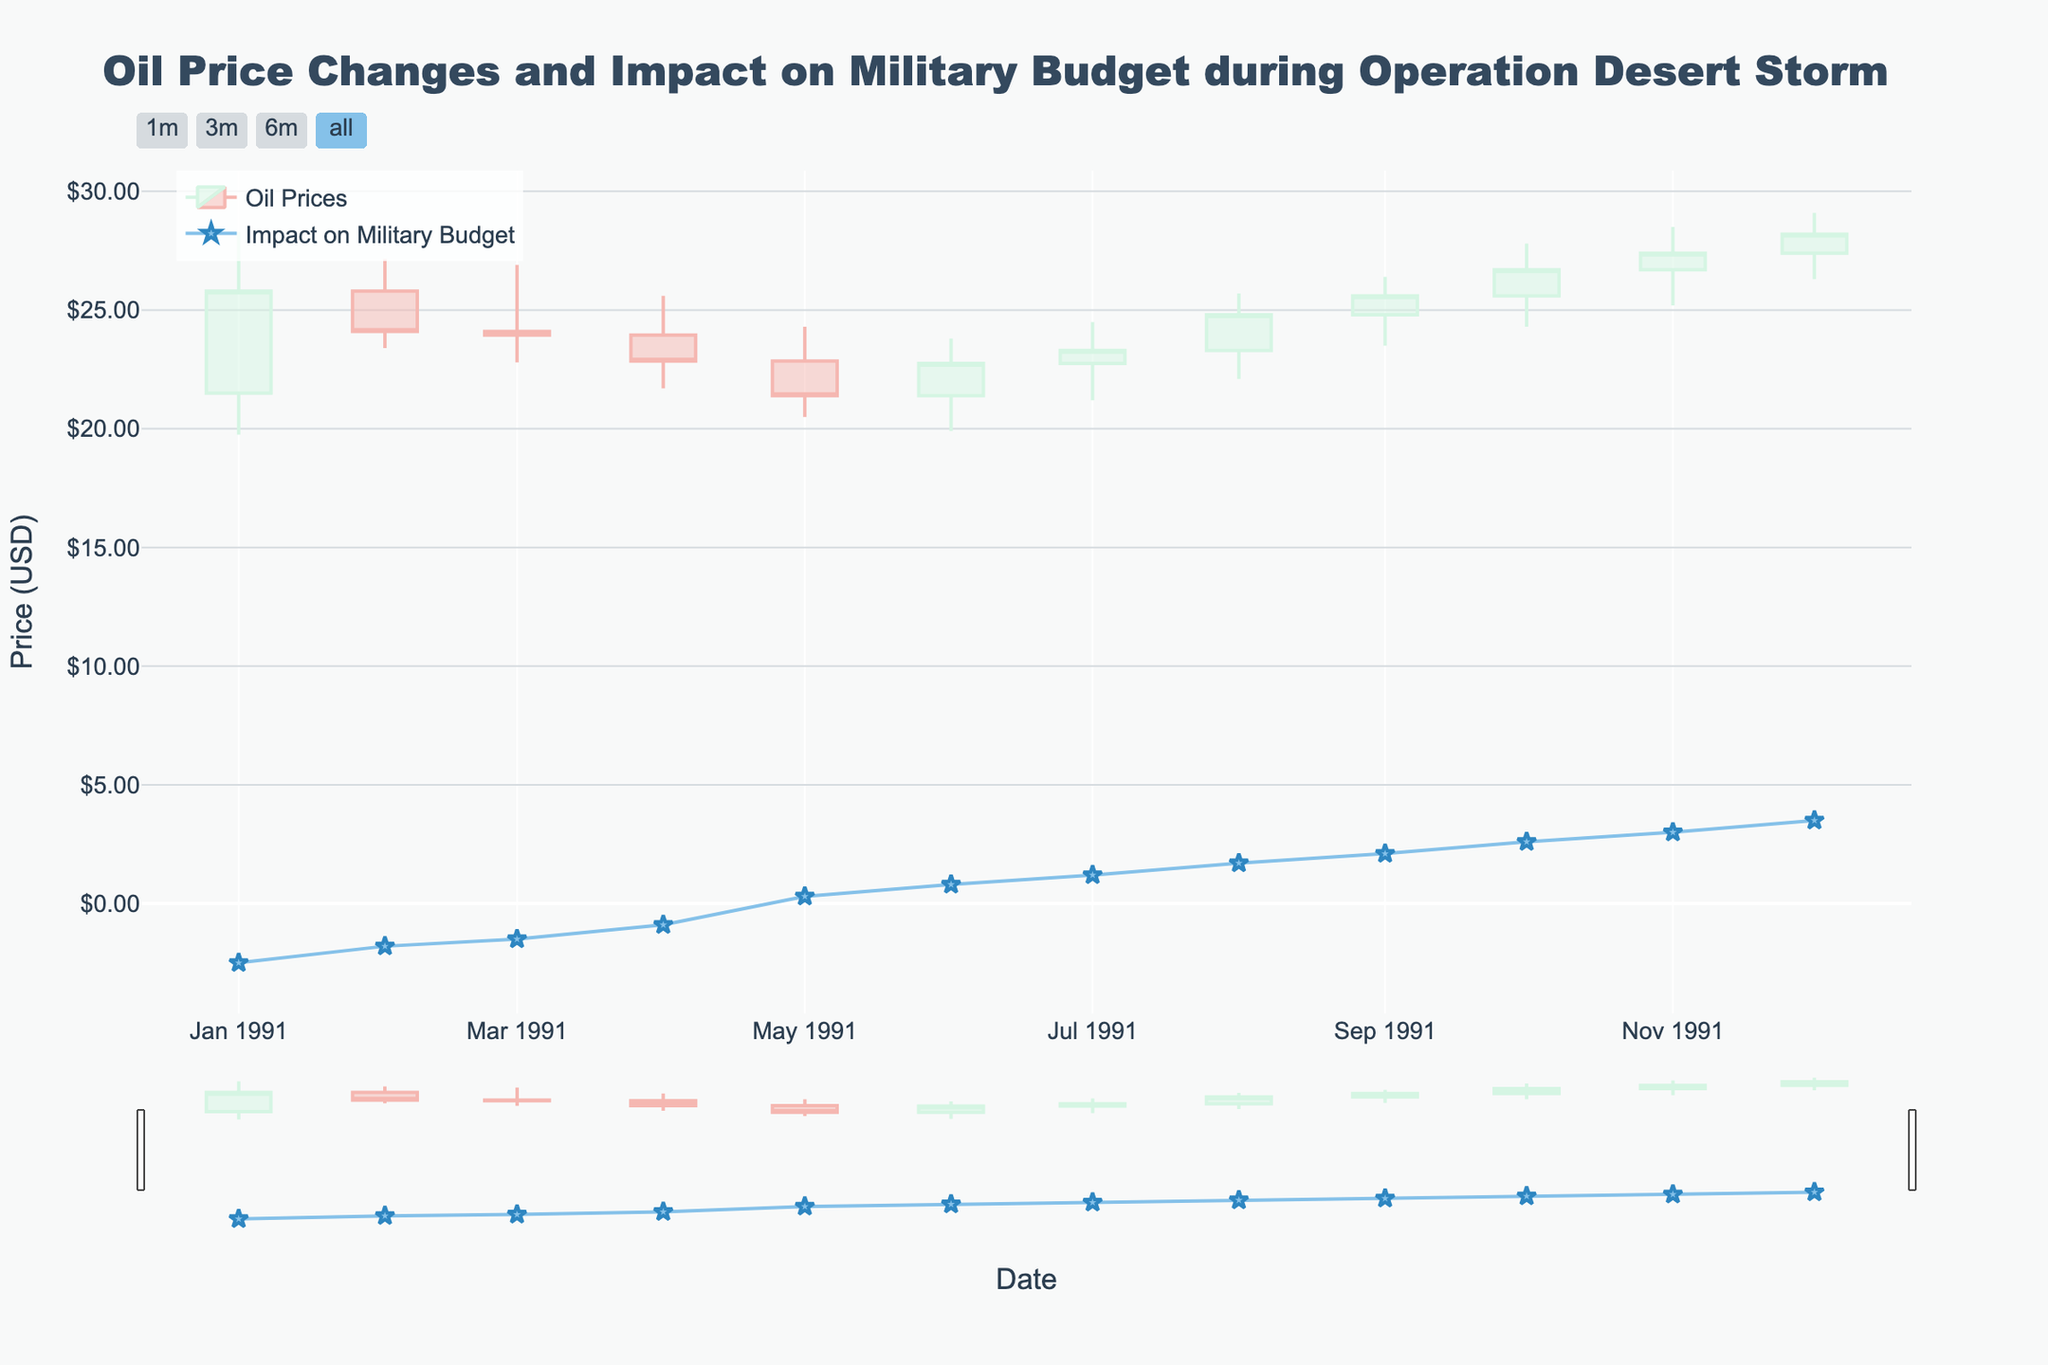what is the highest oil price recorded and when? By analyzing the figure, locate the point with the highest value in the 'High' series, then note the corresponding date.
Answer: $29.10 on December 1991 what was the opening oil price at the beginning of Operation Desert Storm in January 1991? Find the data point for January 1991 and read off the 'Open' value for that month.
Answer: $21.50 how did the oil prices change from January 1991 to December 1991? Compare the 'Close' value in January 1991 to the 'Close' value in December 1991. Observe the overall trend.
Answer: Increased from $25.80 to $28.20 what is the range of oil prices in March 1991? For March 1991, subtract the 'Low' value from the 'High' value.
Answer: $26.90 - $22.80 = $4.10 which month had the highest impact on the military budget? Identify the month corresponding to the highest value in the 'Impact on Military Budget (%)' series.
Answer: December 1991 with 3.5% calculate the average closing price from January 1991 to June 1991 Add up the 'Close' values from January 1991 to June 1991, then divide by the number of months.
Answer: ($25.80 + $24.10 + $23.95 + $22.85 + $21.40 + $22.75) / 6 = $23.48 did oil prices always increase after a decrease in the 'Impact on Military Budget (%)'? Observe the figure to see if each dip in the 'Impact on Military Budget (%)' is followed by an increase in oil prices.
Answer: No, not always how many times did the oil price close higher than it opened within the year? Count the months where the 'Close' value is greater than the 'Open' value.
Answer: 5 times which month experienced the most significant increase in oil prices compared to its previous month? For each month, subtract the previous month's 'Close' value from the current month's 'Close' value and find the greatest positive difference.
Answer: October 1991 What's the correlation between oil prices and the impact on the military budget? Check the general trend in both series. High oil prices tend to coincide with high impacts on the military budget.
Answer: Positive correlation 